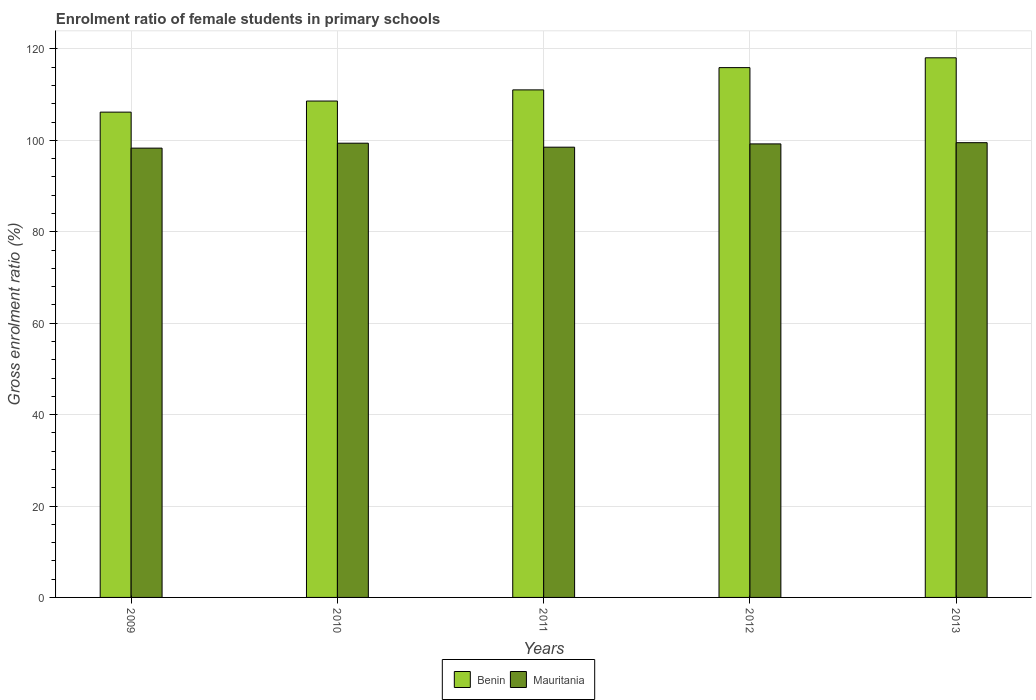How many different coloured bars are there?
Provide a succinct answer. 2. How many bars are there on the 2nd tick from the left?
Your response must be concise. 2. What is the enrolment ratio of female students in primary schools in Benin in 2011?
Offer a terse response. 111.04. Across all years, what is the maximum enrolment ratio of female students in primary schools in Benin?
Your answer should be compact. 118.06. Across all years, what is the minimum enrolment ratio of female students in primary schools in Benin?
Keep it short and to the point. 106.17. In which year was the enrolment ratio of female students in primary schools in Mauritania maximum?
Offer a terse response. 2013. What is the total enrolment ratio of female students in primary schools in Mauritania in the graph?
Provide a short and direct response. 494.9. What is the difference between the enrolment ratio of female students in primary schools in Mauritania in 2010 and that in 2013?
Your response must be concise. -0.11. What is the difference between the enrolment ratio of female students in primary schools in Benin in 2011 and the enrolment ratio of female students in primary schools in Mauritania in 2010?
Keep it short and to the point. 11.67. What is the average enrolment ratio of female students in primary schools in Benin per year?
Provide a succinct answer. 111.96. In the year 2013, what is the difference between the enrolment ratio of female students in primary schools in Benin and enrolment ratio of female students in primary schools in Mauritania?
Ensure brevity in your answer.  18.57. In how many years, is the enrolment ratio of female students in primary schools in Mauritania greater than 60 %?
Ensure brevity in your answer.  5. What is the ratio of the enrolment ratio of female students in primary schools in Benin in 2012 to that in 2013?
Offer a very short reply. 0.98. What is the difference between the highest and the second highest enrolment ratio of female students in primary schools in Benin?
Make the answer very short. 2.14. What is the difference between the highest and the lowest enrolment ratio of female students in primary schools in Benin?
Offer a very short reply. 11.89. Is the sum of the enrolment ratio of female students in primary schools in Mauritania in 2009 and 2010 greater than the maximum enrolment ratio of female students in primary schools in Benin across all years?
Provide a succinct answer. Yes. What does the 1st bar from the left in 2012 represents?
Ensure brevity in your answer.  Benin. What does the 2nd bar from the right in 2013 represents?
Offer a terse response. Benin. How many bars are there?
Keep it short and to the point. 10. How many years are there in the graph?
Your answer should be very brief. 5. What is the difference between two consecutive major ticks on the Y-axis?
Provide a succinct answer. 20. Are the values on the major ticks of Y-axis written in scientific E-notation?
Your answer should be very brief. No. Does the graph contain any zero values?
Provide a succinct answer. No. Does the graph contain grids?
Offer a very short reply. Yes. Where does the legend appear in the graph?
Keep it short and to the point. Bottom center. How are the legend labels stacked?
Offer a very short reply. Horizontal. What is the title of the graph?
Keep it short and to the point. Enrolment ratio of female students in primary schools. What is the label or title of the Y-axis?
Give a very brief answer. Gross enrolment ratio (%). What is the Gross enrolment ratio (%) in Benin in 2009?
Offer a very short reply. 106.17. What is the Gross enrolment ratio (%) of Mauritania in 2009?
Your answer should be very brief. 98.3. What is the Gross enrolment ratio (%) of Benin in 2010?
Your answer should be very brief. 108.6. What is the Gross enrolment ratio (%) of Mauritania in 2010?
Give a very brief answer. 99.38. What is the Gross enrolment ratio (%) in Benin in 2011?
Ensure brevity in your answer.  111.04. What is the Gross enrolment ratio (%) in Mauritania in 2011?
Your answer should be very brief. 98.51. What is the Gross enrolment ratio (%) in Benin in 2012?
Offer a very short reply. 115.92. What is the Gross enrolment ratio (%) in Mauritania in 2012?
Offer a terse response. 99.22. What is the Gross enrolment ratio (%) of Benin in 2013?
Provide a short and direct response. 118.06. What is the Gross enrolment ratio (%) of Mauritania in 2013?
Offer a very short reply. 99.49. Across all years, what is the maximum Gross enrolment ratio (%) of Benin?
Make the answer very short. 118.06. Across all years, what is the maximum Gross enrolment ratio (%) in Mauritania?
Keep it short and to the point. 99.49. Across all years, what is the minimum Gross enrolment ratio (%) in Benin?
Your answer should be compact. 106.17. Across all years, what is the minimum Gross enrolment ratio (%) of Mauritania?
Your response must be concise. 98.3. What is the total Gross enrolment ratio (%) of Benin in the graph?
Your answer should be very brief. 559.8. What is the total Gross enrolment ratio (%) in Mauritania in the graph?
Give a very brief answer. 494.9. What is the difference between the Gross enrolment ratio (%) of Benin in 2009 and that in 2010?
Provide a succinct answer. -2.43. What is the difference between the Gross enrolment ratio (%) of Mauritania in 2009 and that in 2010?
Your response must be concise. -1.08. What is the difference between the Gross enrolment ratio (%) in Benin in 2009 and that in 2011?
Your answer should be very brief. -4.87. What is the difference between the Gross enrolment ratio (%) in Mauritania in 2009 and that in 2011?
Your answer should be very brief. -0.21. What is the difference between the Gross enrolment ratio (%) in Benin in 2009 and that in 2012?
Keep it short and to the point. -9.74. What is the difference between the Gross enrolment ratio (%) in Mauritania in 2009 and that in 2012?
Provide a short and direct response. -0.93. What is the difference between the Gross enrolment ratio (%) in Benin in 2009 and that in 2013?
Offer a terse response. -11.89. What is the difference between the Gross enrolment ratio (%) in Mauritania in 2009 and that in 2013?
Give a very brief answer. -1.19. What is the difference between the Gross enrolment ratio (%) in Benin in 2010 and that in 2011?
Provide a succinct answer. -2.44. What is the difference between the Gross enrolment ratio (%) of Mauritania in 2010 and that in 2011?
Ensure brevity in your answer.  0.87. What is the difference between the Gross enrolment ratio (%) in Benin in 2010 and that in 2012?
Offer a terse response. -7.32. What is the difference between the Gross enrolment ratio (%) of Mauritania in 2010 and that in 2012?
Ensure brevity in your answer.  0.15. What is the difference between the Gross enrolment ratio (%) in Benin in 2010 and that in 2013?
Your answer should be compact. -9.46. What is the difference between the Gross enrolment ratio (%) of Mauritania in 2010 and that in 2013?
Your response must be concise. -0.11. What is the difference between the Gross enrolment ratio (%) of Benin in 2011 and that in 2012?
Keep it short and to the point. -4.87. What is the difference between the Gross enrolment ratio (%) of Mauritania in 2011 and that in 2012?
Make the answer very short. -0.72. What is the difference between the Gross enrolment ratio (%) in Benin in 2011 and that in 2013?
Give a very brief answer. -7.02. What is the difference between the Gross enrolment ratio (%) of Mauritania in 2011 and that in 2013?
Your answer should be compact. -0.98. What is the difference between the Gross enrolment ratio (%) in Benin in 2012 and that in 2013?
Your answer should be compact. -2.15. What is the difference between the Gross enrolment ratio (%) of Mauritania in 2012 and that in 2013?
Ensure brevity in your answer.  -0.27. What is the difference between the Gross enrolment ratio (%) of Benin in 2009 and the Gross enrolment ratio (%) of Mauritania in 2010?
Your response must be concise. 6.8. What is the difference between the Gross enrolment ratio (%) in Benin in 2009 and the Gross enrolment ratio (%) in Mauritania in 2011?
Your answer should be compact. 7.67. What is the difference between the Gross enrolment ratio (%) of Benin in 2009 and the Gross enrolment ratio (%) of Mauritania in 2012?
Offer a terse response. 6.95. What is the difference between the Gross enrolment ratio (%) of Benin in 2009 and the Gross enrolment ratio (%) of Mauritania in 2013?
Your response must be concise. 6.68. What is the difference between the Gross enrolment ratio (%) in Benin in 2010 and the Gross enrolment ratio (%) in Mauritania in 2011?
Your response must be concise. 10.09. What is the difference between the Gross enrolment ratio (%) in Benin in 2010 and the Gross enrolment ratio (%) in Mauritania in 2012?
Provide a succinct answer. 9.38. What is the difference between the Gross enrolment ratio (%) in Benin in 2010 and the Gross enrolment ratio (%) in Mauritania in 2013?
Your answer should be compact. 9.11. What is the difference between the Gross enrolment ratio (%) of Benin in 2011 and the Gross enrolment ratio (%) of Mauritania in 2012?
Provide a succinct answer. 11.82. What is the difference between the Gross enrolment ratio (%) of Benin in 2011 and the Gross enrolment ratio (%) of Mauritania in 2013?
Provide a succinct answer. 11.55. What is the difference between the Gross enrolment ratio (%) in Benin in 2012 and the Gross enrolment ratio (%) in Mauritania in 2013?
Ensure brevity in your answer.  16.43. What is the average Gross enrolment ratio (%) of Benin per year?
Provide a succinct answer. 111.96. What is the average Gross enrolment ratio (%) of Mauritania per year?
Give a very brief answer. 98.98. In the year 2009, what is the difference between the Gross enrolment ratio (%) in Benin and Gross enrolment ratio (%) in Mauritania?
Keep it short and to the point. 7.88. In the year 2010, what is the difference between the Gross enrolment ratio (%) of Benin and Gross enrolment ratio (%) of Mauritania?
Offer a terse response. 9.22. In the year 2011, what is the difference between the Gross enrolment ratio (%) in Benin and Gross enrolment ratio (%) in Mauritania?
Your response must be concise. 12.54. In the year 2012, what is the difference between the Gross enrolment ratio (%) of Benin and Gross enrolment ratio (%) of Mauritania?
Keep it short and to the point. 16.69. In the year 2013, what is the difference between the Gross enrolment ratio (%) of Benin and Gross enrolment ratio (%) of Mauritania?
Your answer should be compact. 18.57. What is the ratio of the Gross enrolment ratio (%) in Benin in 2009 to that in 2010?
Your answer should be very brief. 0.98. What is the ratio of the Gross enrolment ratio (%) of Benin in 2009 to that in 2011?
Your answer should be compact. 0.96. What is the ratio of the Gross enrolment ratio (%) of Benin in 2009 to that in 2012?
Offer a very short reply. 0.92. What is the ratio of the Gross enrolment ratio (%) in Mauritania in 2009 to that in 2012?
Provide a succinct answer. 0.99. What is the ratio of the Gross enrolment ratio (%) of Benin in 2009 to that in 2013?
Ensure brevity in your answer.  0.9. What is the ratio of the Gross enrolment ratio (%) in Mauritania in 2009 to that in 2013?
Keep it short and to the point. 0.99. What is the ratio of the Gross enrolment ratio (%) of Mauritania in 2010 to that in 2011?
Give a very brief answer. 1.01. What is the ratio of the Gross enrolment ratio (%) in Benin in 2010 to that in 2012?
Make the answer very short. 0.94. What is the ratio of the Gross enrolment ratio (%) of Benin in 2010 to that in 2013?
Give a very brief answer. 0.92. What is the ratio of the Gross enrolment ratio (%) of Benin in 2011 to that in 2012?
Provide a succinct answer. 0.96. What is the ratio of the Gross enrolment ratio (%) of Mauritania in 2011 to that in 2012?
Provide a succinct answer. 0.99. What is the ratio of the Gross enrolment ratio (%) of Benin in 2011 to that in 2013?
Keep it short and to the point. 0.94. What is the ratio of the Gross enrolment ratio (%) of Mauritania in 2011 to that in 2013?
Your answer should be compact. 0.99. What is the ratio of the Gross enrolment ratio (%) in Benin in 2012 to that in 2013?
Keep it short and to the point. 0.98. What is the ratio of the Gross enrolment ratio (%) of Mauritania in 2012 to that in 2013?
Give a very brief answer. 1. What is the difference between the highest and the second highest Gross enrolment ratio (%) of Benin?
Your response must be concise. 2.15. What is the difference between the highest and the second highest Gross enrolment ratio (%) of Mauritania?
Make the answer very short. 0.11. What is the difference between the highest and the lowest Gross enrolment ratio (%) of Benin?
Your answer should be compact. 11.89. What is the difference between the highest and the lowest Gross enrolment ratio (%) of Mauritania?
Keep it short and to the point. 1.19. 